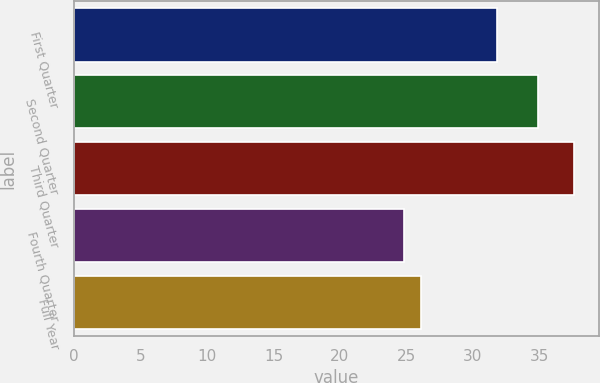<chart> <loc_0><loc_0><loc_500><loc_500><bar_chart><fcel>First Quarter<fcel>Second Quarter<fcel>Third Quarter<fcel>Fourth Quarter<fcel>Full Year<nl><fcel>31.81<fcel>34.9<fcel>37.59<fcel>24.8<fcel>26.08<nl></chart> 